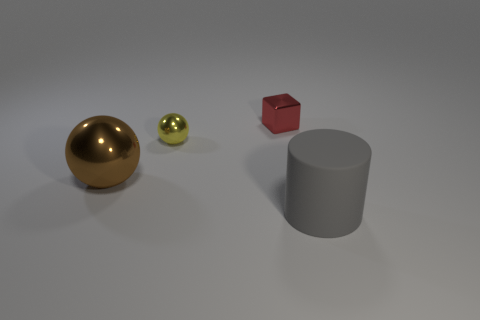Add 1 brown objects. How many objects exist? 5 Add 1 tiny gray cubes. How many tiny gray cubes exist? 1 Subtract 1 gray cylinders. How many objects are left? 3 Subtract all yellow objects. Subtract all small red metallic cubes. How many objects are left? 2 Add 4 metallic cubes. How many metallic cubes are left? 5 